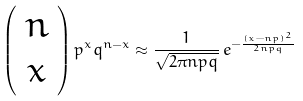Convert formula to latex. <formula><loc_0><loc_0><loc_500><loc_500>\left ( \begin{array} { c c c } n \\ x \end{array} \right ) p ^ { x } q ^ { n - x } \approx \frac { 1 } { \sqrt { 2 \pi n p q } } \, e ^ { - \frac { ( x - n p ) ^ { 2 } } { 2 n p q } }</formula> 